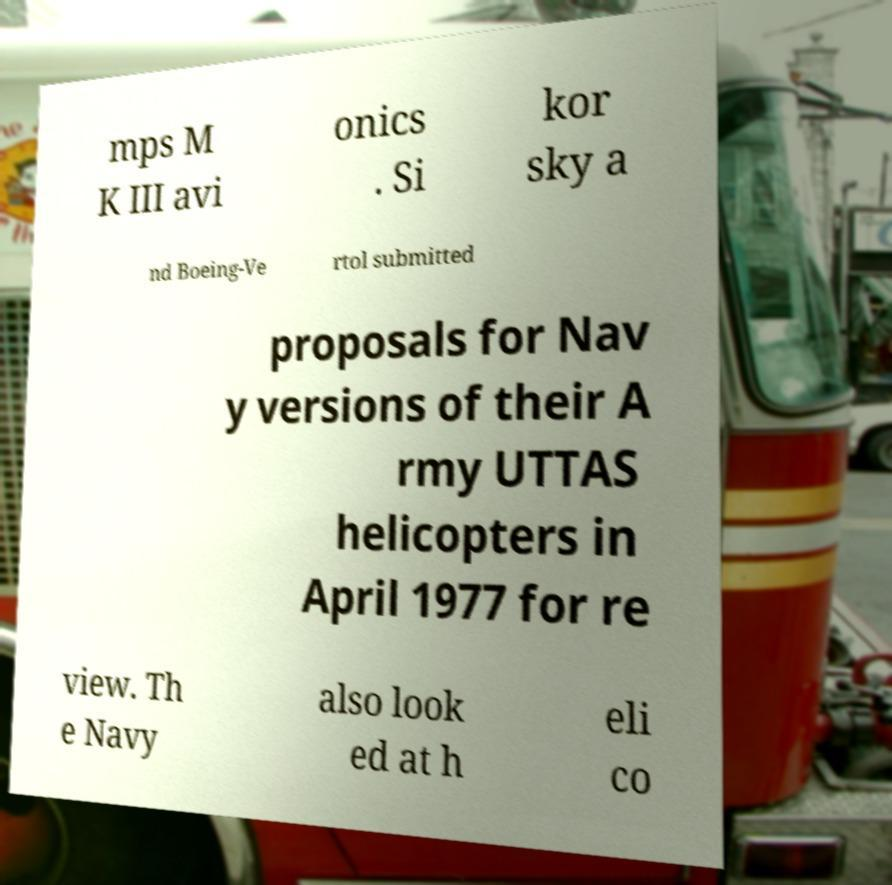Could you assist in decoding the text presented in this image and type it out clearly? mps M K III avi onics . Si kor sky a nd Boeing-Ve rtol submitted proposals for Nav y versions of their A rmy UTTAS helicopters in April 1977 for re view. Th e Navy also look ed at h eli co 